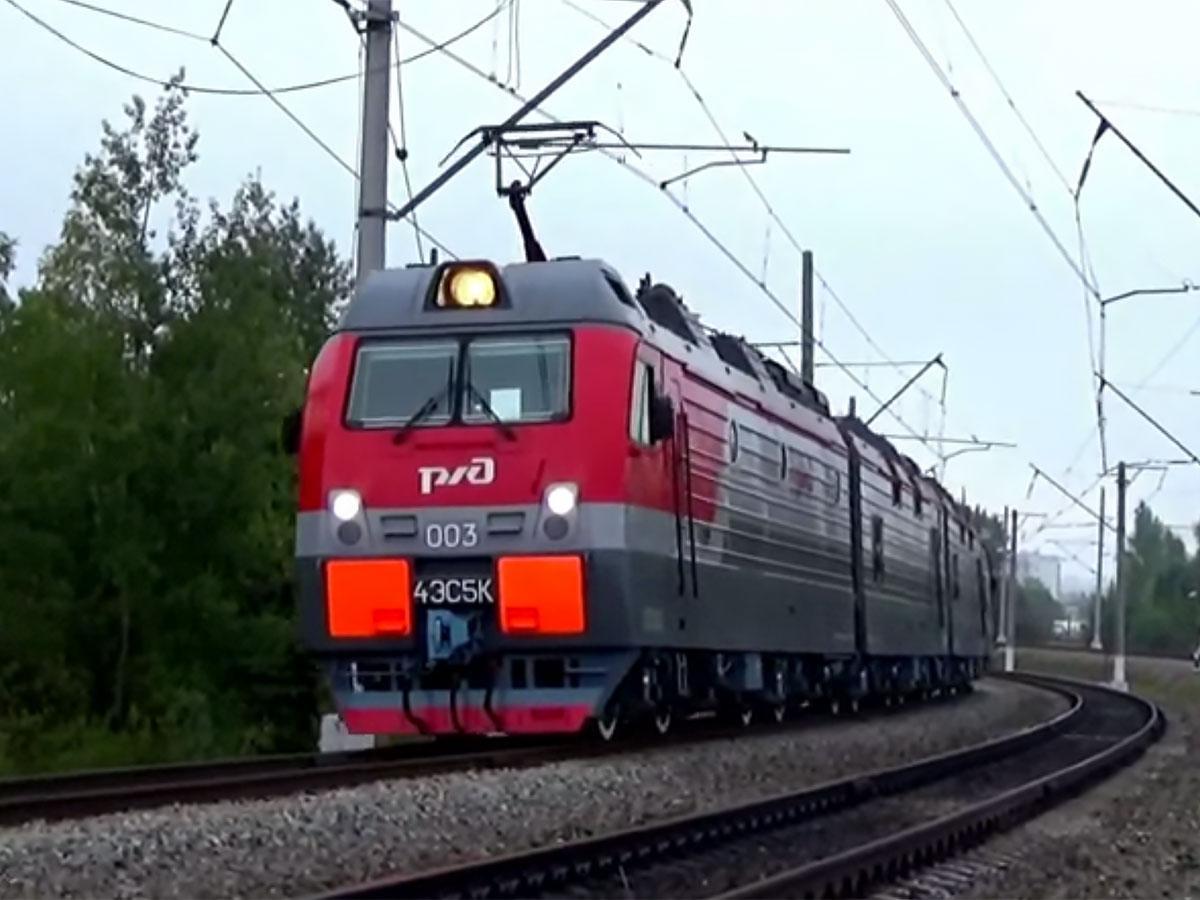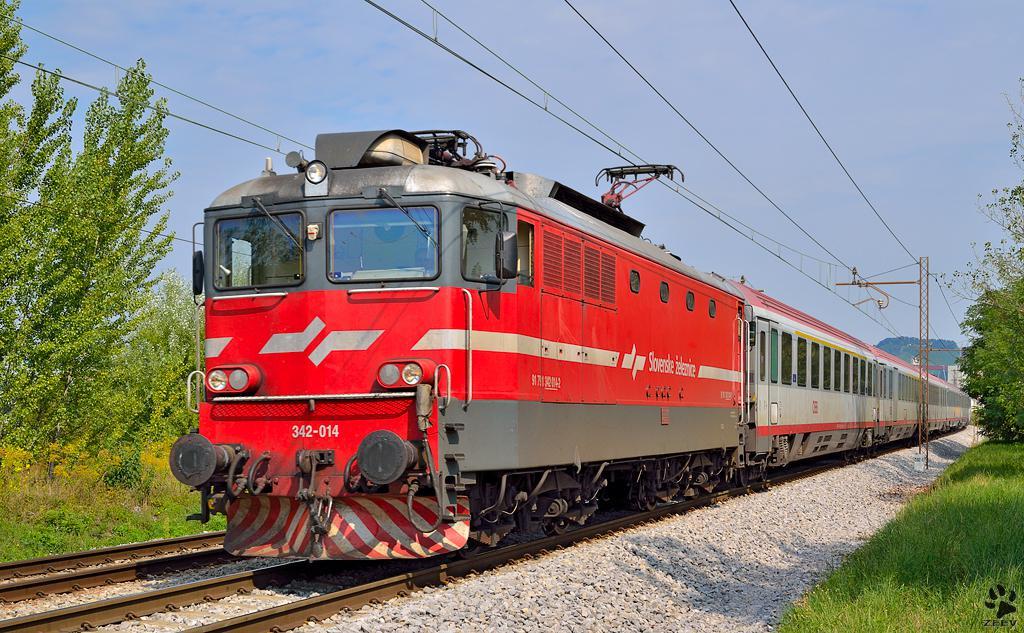The first image is the image on the left, the second image is the image on the right. Given the left and right images, does the statement "All trains are angled forward in the same direction." hold true? Answer yes or no. Yes. The first image is the image on the left, the second image is the image on the right. Examine the images to the left and right. Is the description "There are two red trains sitting on train tracks." accurate? Answer yes or no. Yes. 